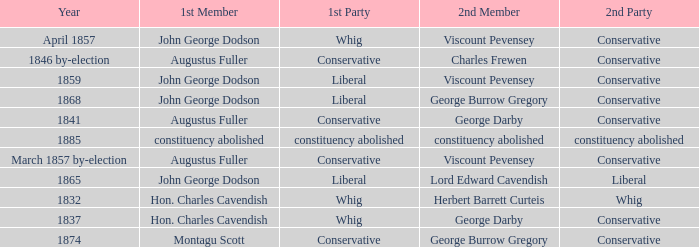In 1837, who was the 2nd member who's 2nd party was conservative. George Darby. 